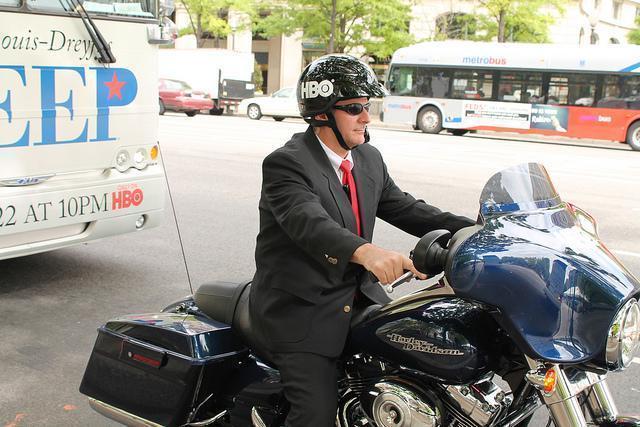The man on the motorcycle is pretending to act as what type of person?
Answer the question by selecting the correct answer among the 4 following choices.
Options: Policeman, businessman, secret serviceman, fireman. Secret serviceman. 